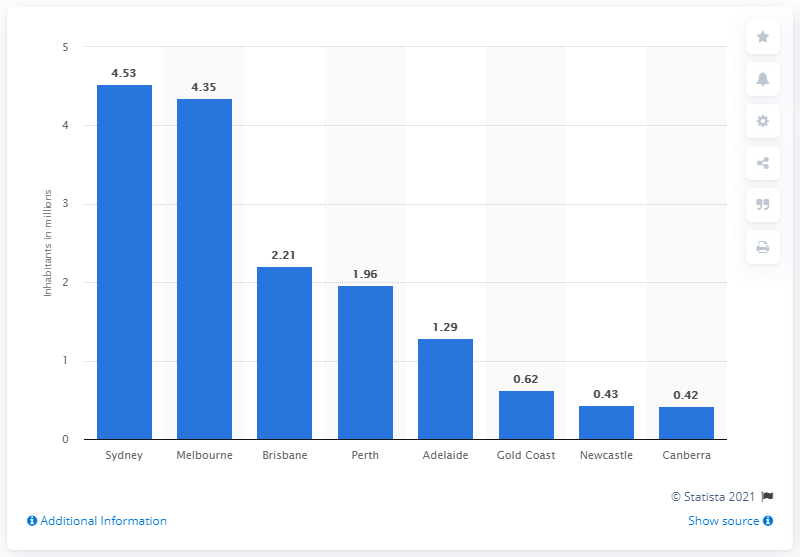Outline some significant characteristics in this image. The city with the highest population in Australia is Sydney. In 2015, approximately 4.53 million individuals resided in Sydney. 